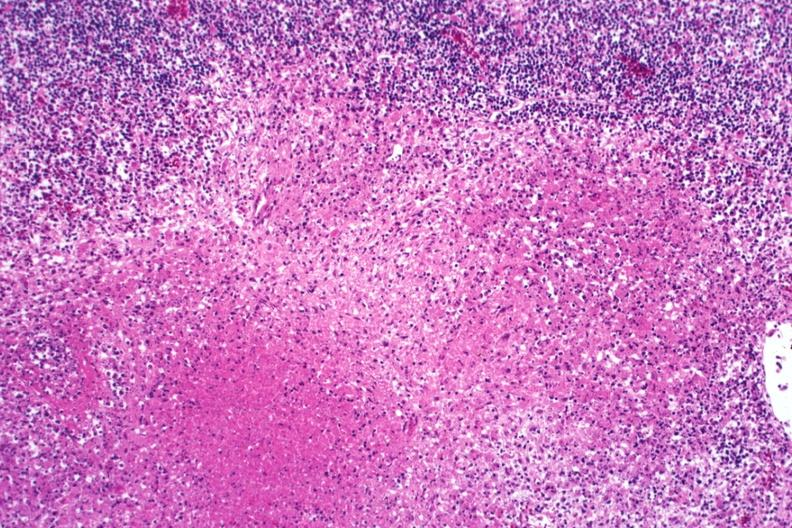does clostridial postmortem growth show typical necrotizing granulomas?
Answer the question using a single word or phrase. No 